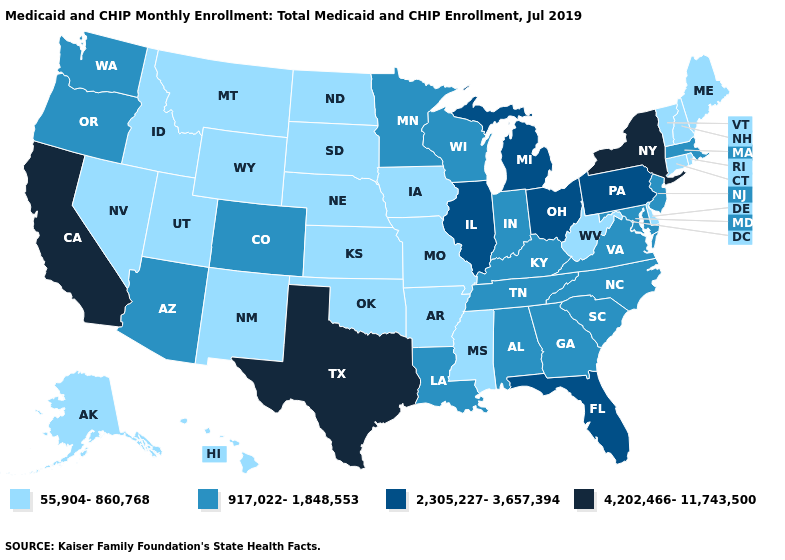What is the value of Arkansas?
Write a very short answer. 55,904-860,768. Is the legend a continuous bar?
Write a very short answer. No. Name the states that have a value in the range 917,022-1,848,553?
Be succinct. Alabama, Arizona, Colorado, Georgia, Indiana, Kentucky, Louisiana, Maryland, Massachusetts, Minnesota, New Jersey, North Carolina, Oregon, South Carolina, Tennessee, Virginia, Washington, Wisconsin. What is the value of California?
Concise answer only. 4,202,466-11,743,500. Does the first symbol in the legend represent the smallest category?
Be succinct. Yes. What is the value of Georgia?
Concise answer only. 917,022-1,848,553. What is the highest value in the Northeast ?
Short answer required. 4,202,466-11,743,500. Which states have the lowest value in the USA?
Be succinct. Alaska, Arkansas, Connecticut, Delaware, Hawaii, Idaho, Iowa, Kansas, Maine, Mississippi, Missouri, Montana, Nebraska, Nevada, New Hampshire, New Mexico, North Dakota, Oklahoma, Rhode Island, South Dakota, Utah, Vermont, West Virginia, Wyoming. Does Oregon have the highest value in the USA?
Answer briefly. No. What is the value of Kentucky?
Write a very short answer. 917,022-1,848,553. Does the first symbol in the legend represent the smallest category?
Keep it brief. Yes. Name the states that have a value in the range 4,202,466-11,743,500?
Quick response, please. California, New York, Texas. Name the states that have a value in the range 2,305,227-3,657,394?
Give a very brief answer. Florida, Illinois, Michigan, Ohio, Pennsylvania. What is the value of Virginia?
Write a very short answer. 917,022-1,848,553. Among the states that border Idaho , which have the lowest value?
Give a very brief answer. Montana, Nevada, Utah, Wyoming. 